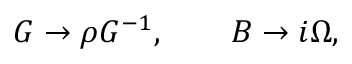Convert formula to latex. <formula><loc_0><loc_0><loc_500><loc_500>G \rightarrow \rho G ^ { - 1 } , \quad B \rightarrow i \Omega ,</formula> 